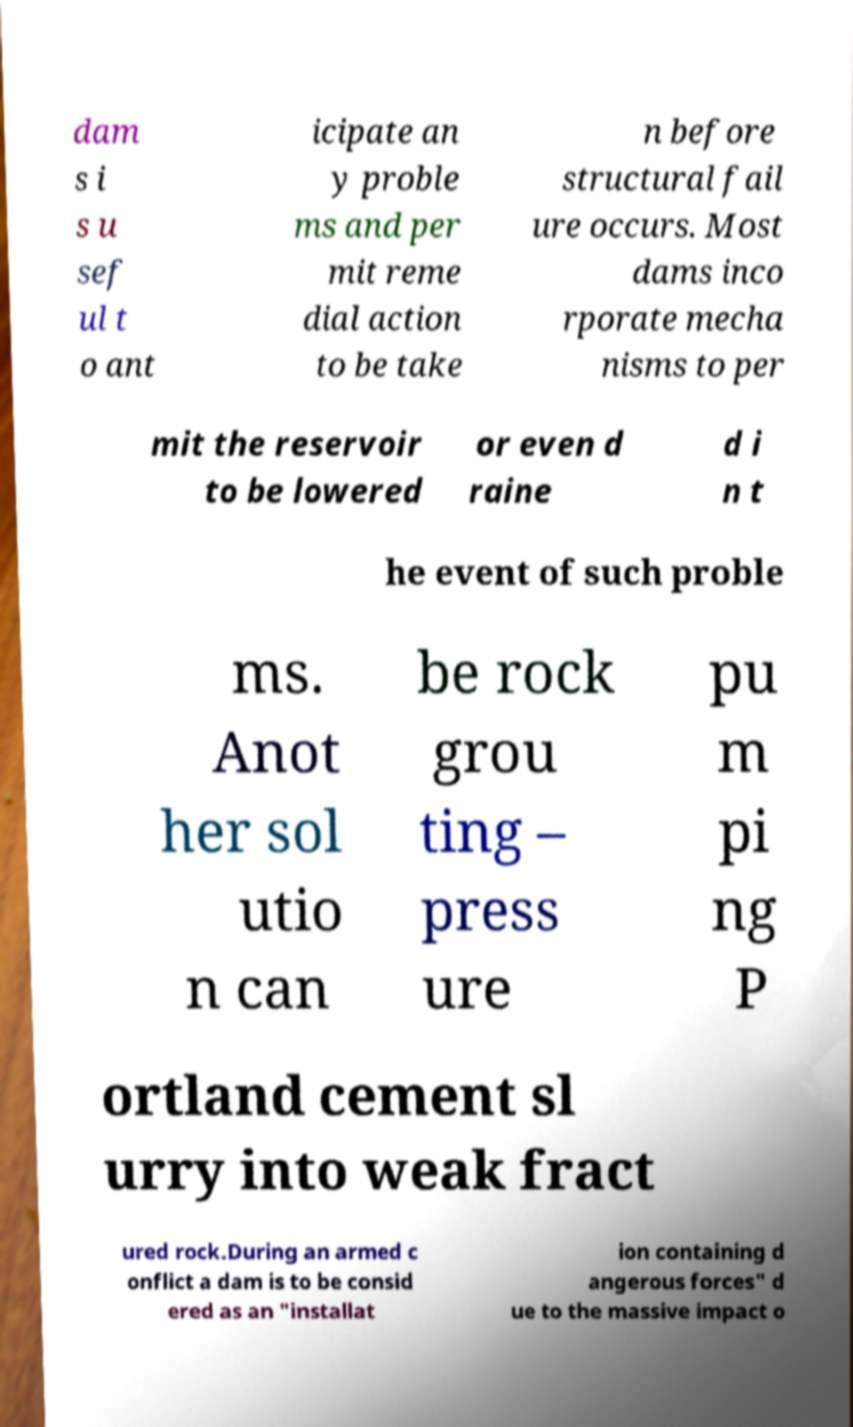I need the written content from this picture converted into text. Can you do that? dam s i s u sef ul t o ant icipate an y proble ms and per mit reme dial action to be take n before structural fail ure occurs. Most dams inco rporate mecha nisms to per mit the reservoir to be lowered or even d raine d i n t he event of such proble ms. Anot her sol utio n can be rock grou ting – press ure pu m pi ng P ortland cement sl urry into weak fract ured rock.During an armed c onflict a dam is to be consid ered as an "installat ion containing d angerous forces" d ue to the massive impact o 